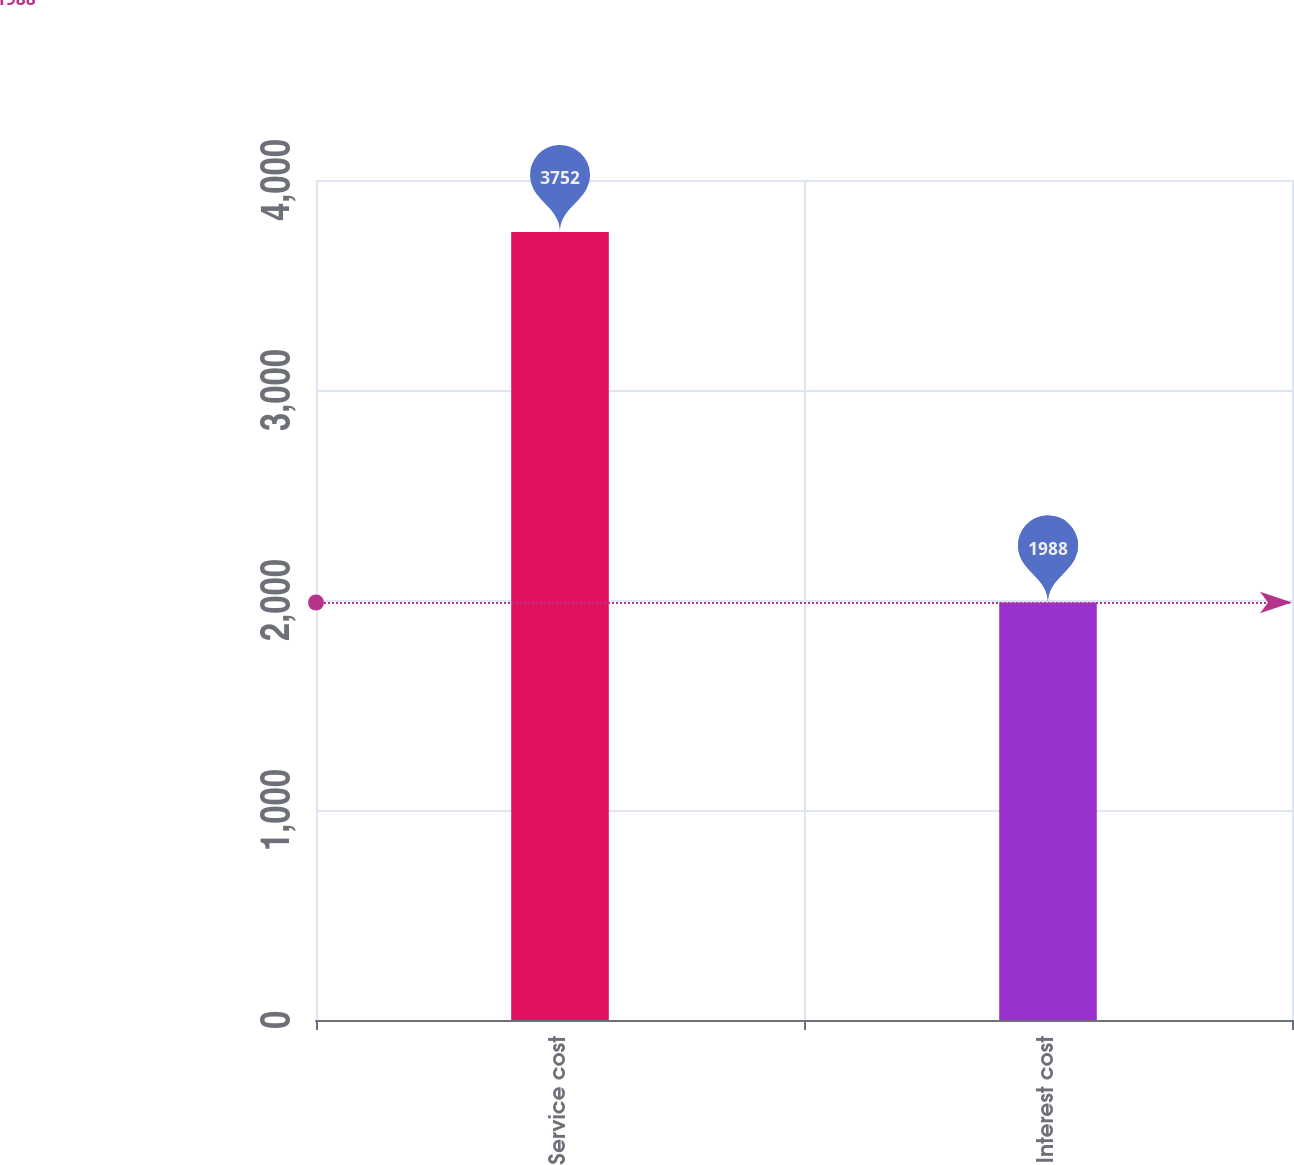Convert chart. <chart><loc_0><loc_0><loc_500><loc_500><bar_chart><fcel>Service cost<fcel>Interest cost<nl><fcel>3752<fcel>1988<nl></chart> 